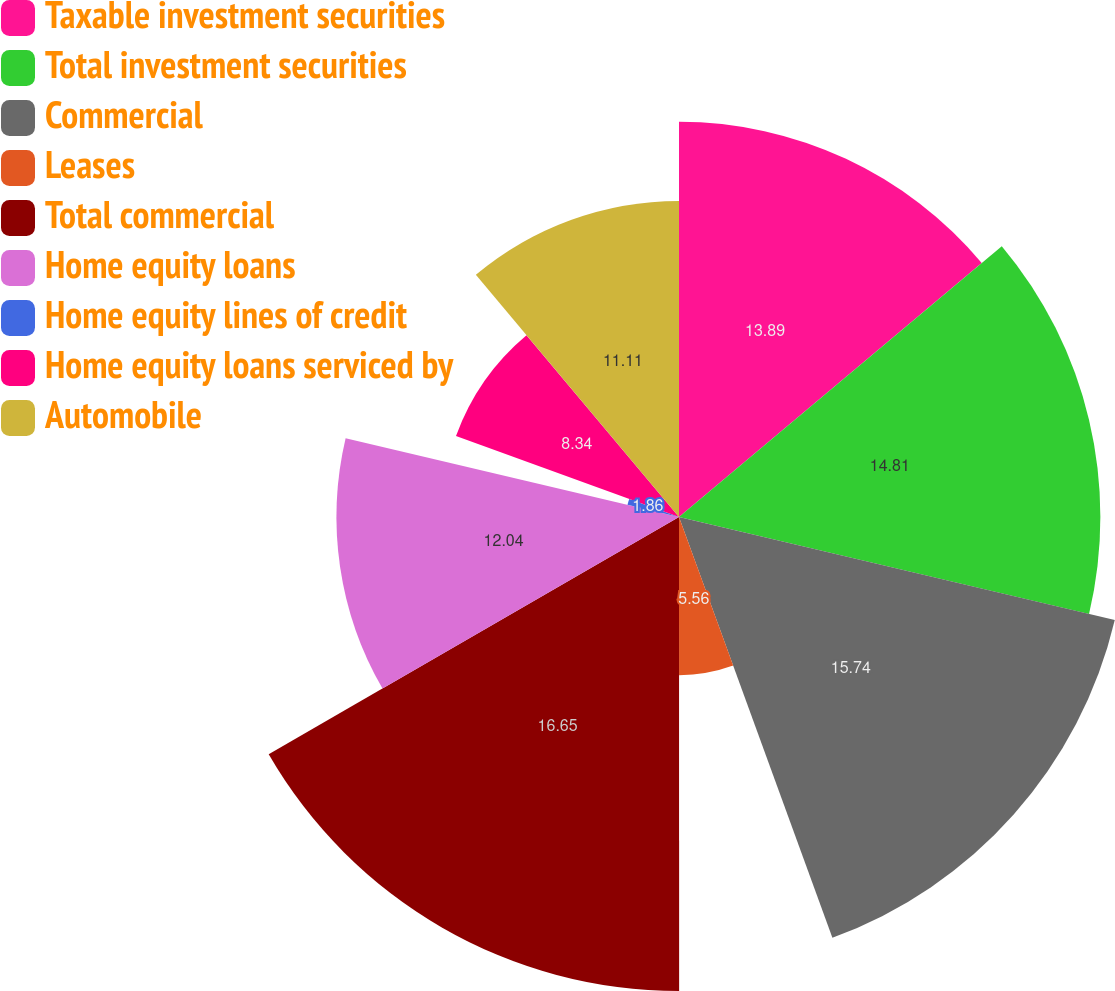Convert chart to OTSL. <chart><loc_0><loc_0><loc_500><loc_500><pie_chart><fcel>Taxable investment securities<fcel>Total investment securities<fcel>Commercial<fcel>Leases<fcel>Total commercial<fcel>Home equity loans<fcel>Home equity lines of credit<fcel>Home equity loans serviced by<fcel>Automobile<nl><fcel>13.89%<fcel>14.81%<fcel>15.74%<fcel>5.56%<fcel>16.66%<fcel>12.04%<fcel>1.86%<fcel>8.34%<fcel>11.11%<nl></chart> 